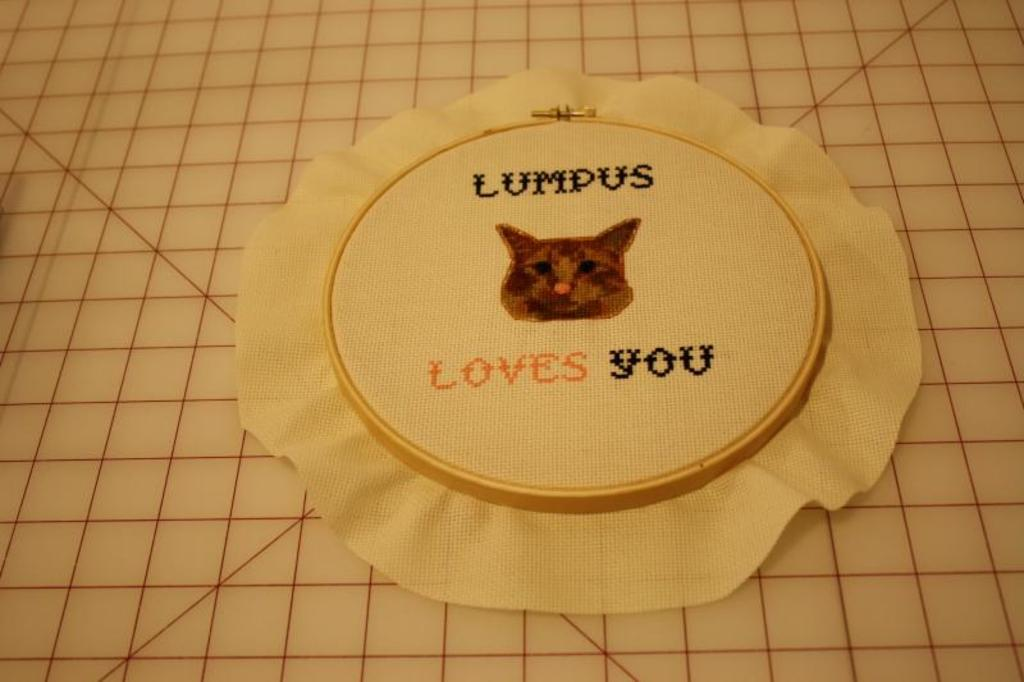What is the person holding in the image? The person is holding a skateboard in the image. What safety precaution is the person taking? The person is wearing a helmet in the image. Where is the person standing in relation to the water? The person is standing near the water in the image. What year is depicted in the image? The image does not depict a specific year; it shows a person holding a skateboard and wearing a helmet near the water. 